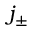Convert formula to latex. <formula><loc_0><loc_0><loc_500><loc_500>j _ { \pm }</formula> 